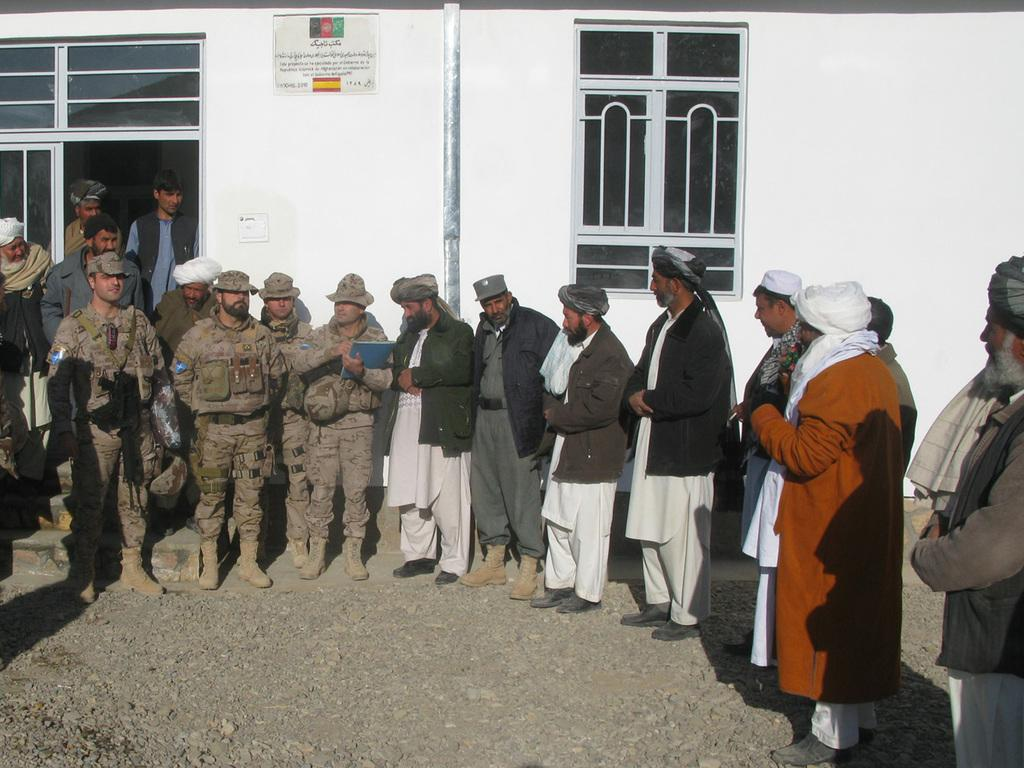How many people are in the image? There is a group of people in the image, but the exact number is not specified. What is the position of the people in the image? The people are on the ground in the image. What can be seen in the background of the image? In the background of the image, there is a wall, a window, a door, a poster, and some objects. Can you describe the poster in the background? The facts provided do not give any details about the poster, so it cannot be described. What type of string is being used by the people in the image? There is no mention of any string in the image, so it cannot be determined what type of string might be used. 